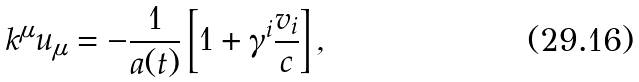Convert formula to latex. <formula><loc_0><loc_0><loc_500><loc_500>k ^ { \mu } u _ { \mu } = - \frac { 1 } { a ( t ) } \left [ 1 + \gamma ^ { i } \frac { v _ { i } } { c } \right ] ,</formula> 